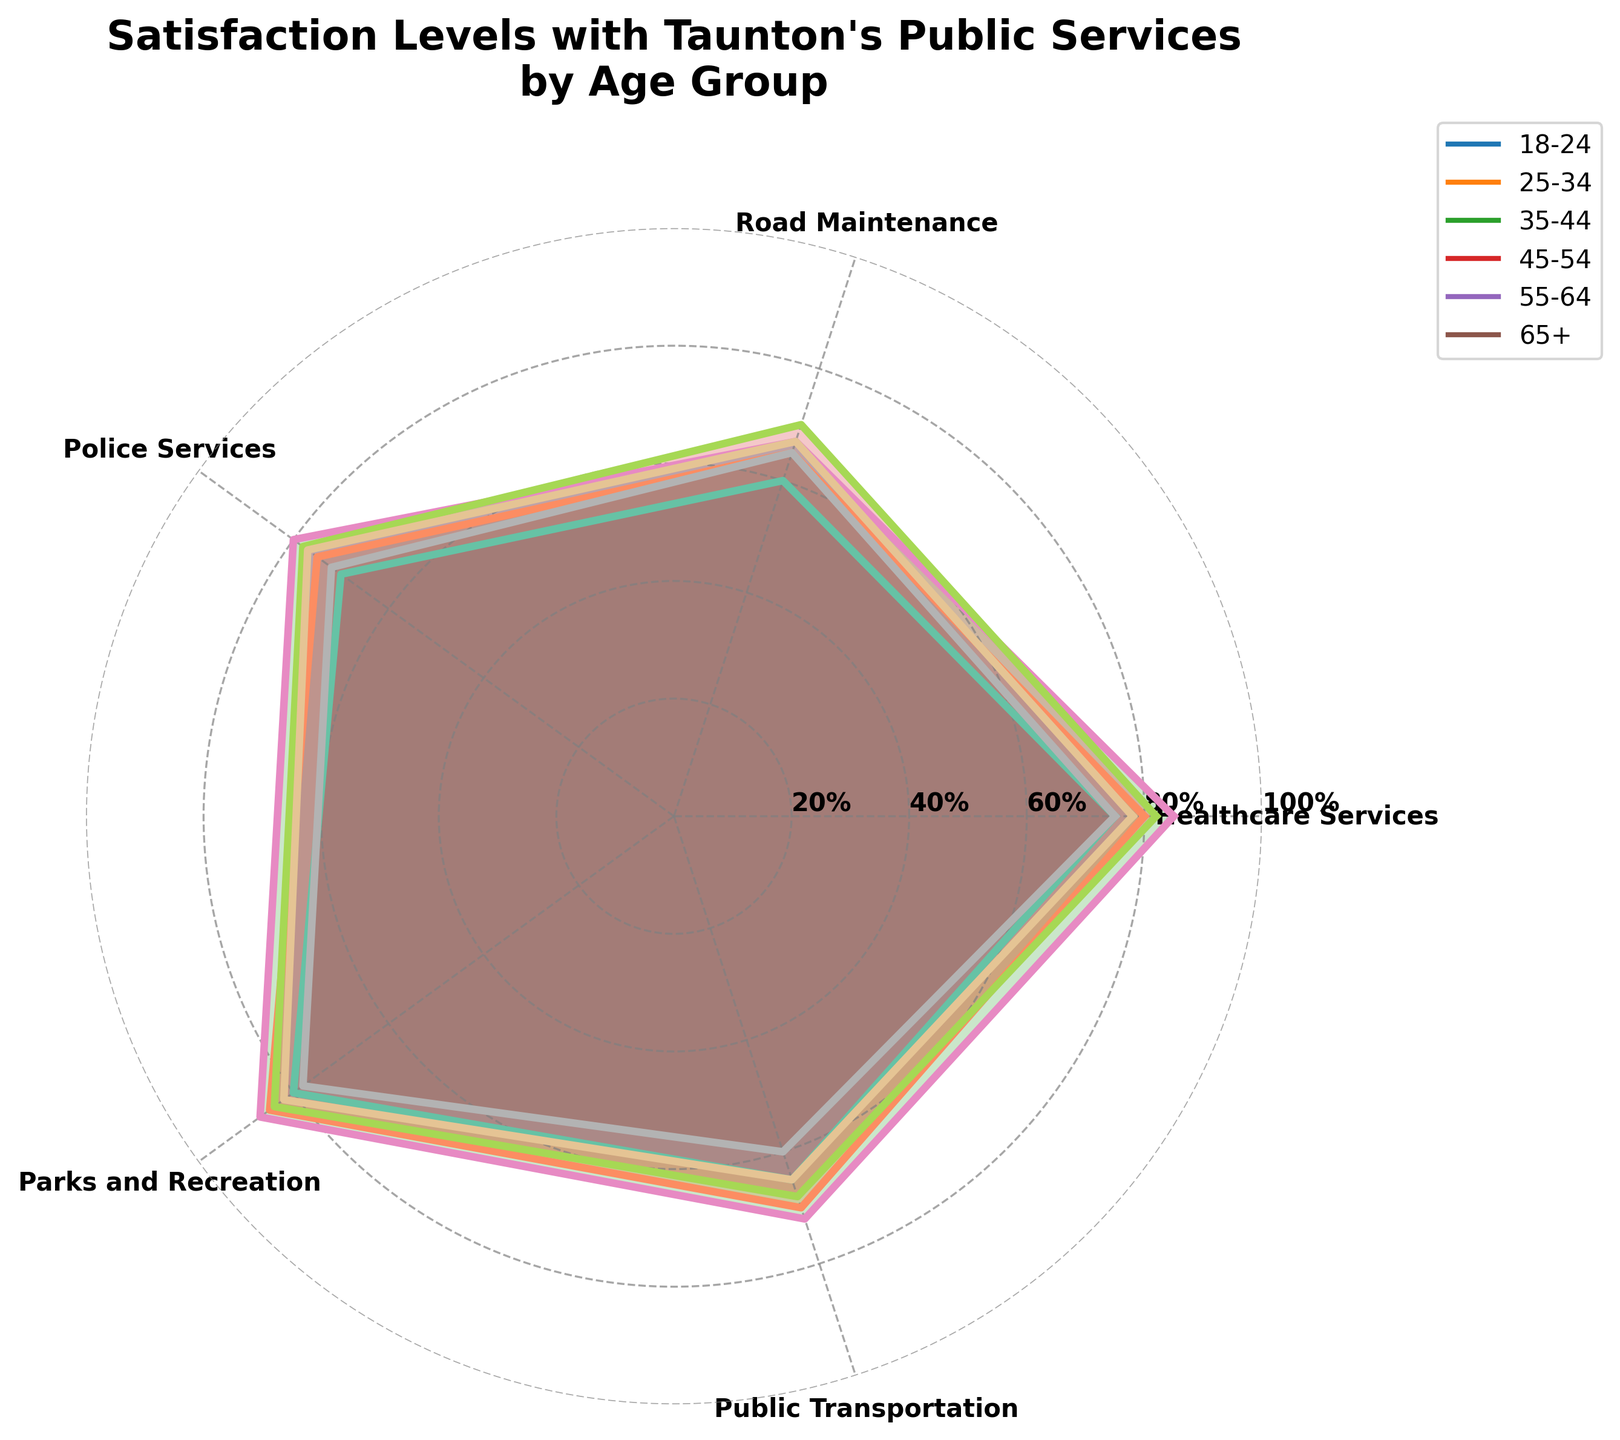What is the title of the chart? The title is typically placed visibly at the top of the chart and is immediately readable.
Answer: "Satisfaction Levels with Taunton's Public Services by Age Group" Which age group has the highest satisfaction level with Healthcare Services? By examining the plotted points, the highest value on the Healthcare Services axis corresponds to the 35-44 age group.
Answer: 35-44 age group Between which two age groups is there the smallest difference in Public Transportation satisfaction levels? Referring to the Public Transportation axis, the values for the 18-24 and 25-34 age groups are closest, both having values of 65 and 70 respectively, making the difference 5.
Answer: 18-24 and 25-34 age groups What is the average satisfaction level for Police Services across all age groups? Adding all the values for Police Services (70, 75, 80, 78, 77, 72) gives 452. Dividing by the 6 age groups, we get 452/6 = 75.33.
Answer: 75.33 Which age group shows the greatest satisfaction with Parks and Recreation services? Observing the Parks and Recreation axis, the highest value of 87 is noted for the 35-44 age group.
Answer: 35-44 age group How does satisfaction with Road Maintenance compare between the 25-34 and 65+ age groups? The 25-34 group has a satisfaction level of 65, while the 65+ group also has a satisfaction level of 65, indicating equal satisfaction levels in both groups.
Answer: Equal satisfaction levels Which public service category shows the most variability in satisfaction levels across different age groups? By comparing the range of satisfaction levels for each category: Healthcare Services varies from 75 to 85, Road Maintenance from 60 to 70, Police Services from 70 to 80, Parks and Recreation from 78 to 87, and Public Transportation from 60 to 72. Parks and Recreation has the largest range of 9.
Answer: Parks and Recreation What is the difference in satisfaction levels for Healthcare Services between the 18-24 and 45-54 age groups? The satisfaction levels for Healthcare Services are 75 and 82 respectively. The difference is 82 - 75 = 7.
Answer: 7 Which age groups have a satisfaction level below 70 for Public Transportation? Public Transportation satisfaction is labeled as follows: 18-24 at 65, 25-34 at 70, 35-44 at 72, 45-54 at 68, 55-64 at 65, and 65+ at 60. The age groups with satisfaction levels below 70 are: 18-24, 45-54, 55-64, and 65+.
Answer: 18-24, 45-54, 55-64, and 65+ 